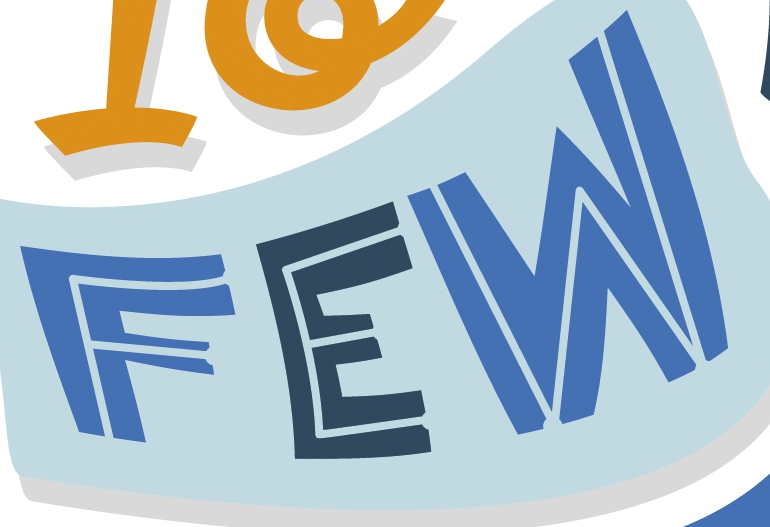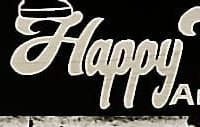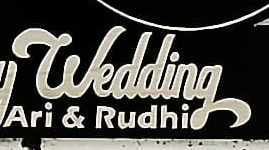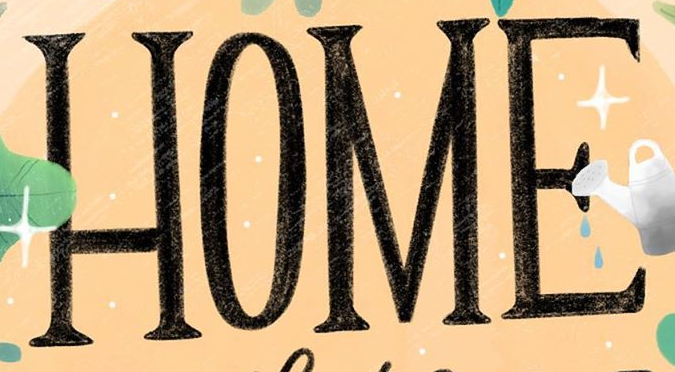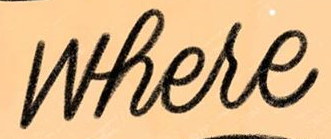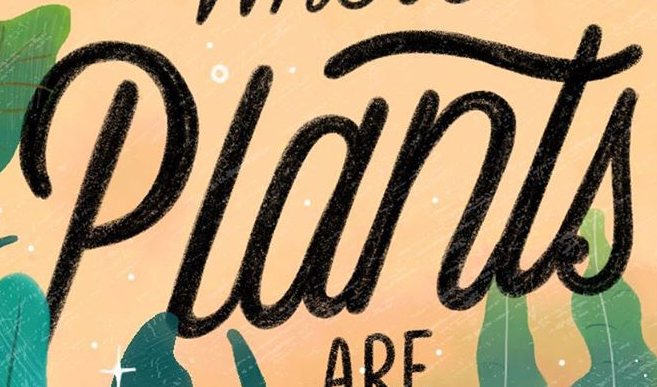Read the text content from these images in order, separated by a semicolon. FEW; Happy; wedding; HOME; where; Plants 